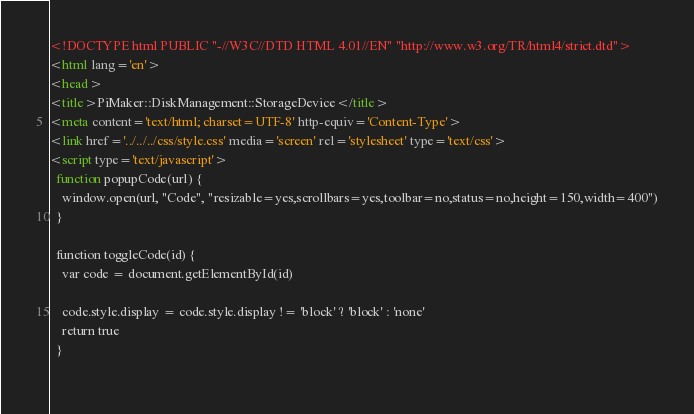<code> <loc_0><loc_0><loc_500><loc_500><_HTML_><!DOCTYPE html PUBLIC "-//W3C//DTD HTML 4.01//EN" "http://www.w3.org/TR/html4/strict.dtd">
<html lang='en'>
<head>
<title>PiMaker::DiskManagement::StorageDevice</title>
<meta content='text/html; charset=UTF-8' http-equiv='Content-Type'>
<link href='../../../css/style.css' media='screen' rel='stylesheet' type='text/css'>
<script type='text/javascript'>
  function popupCode(url) {
    window.open(url, "Code", "resizable=yes,scrollbars=yes,toolbar=no,status=no,height=150,width=400")
  }
  
  function toggleCode(id) {
    var code = document.getElementById(id)
  
    code.style.display = code.style.display != 'block' ? 'block' : 'none'
    return true
  }
  </code> 